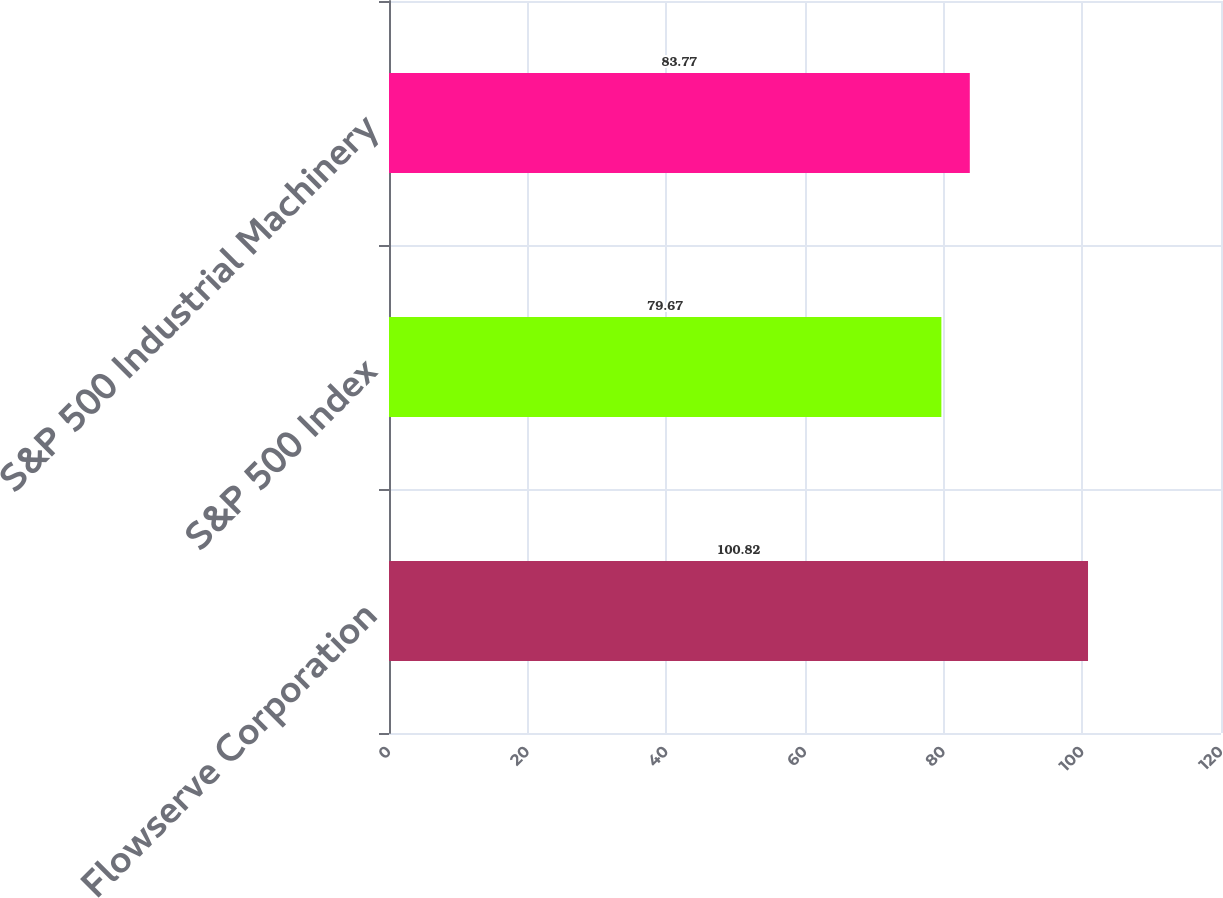Convert chart. <chart><loc_0><loc_0><loc_500><loc_500><bar_chart><fcel>Flowserve Corporation<fcel>S&P 500 Index<fcel>S&P 500 Industrial Machinery<nl><fcel>100.82<fcel>79.67<fcel>83.77<nl></chart> 